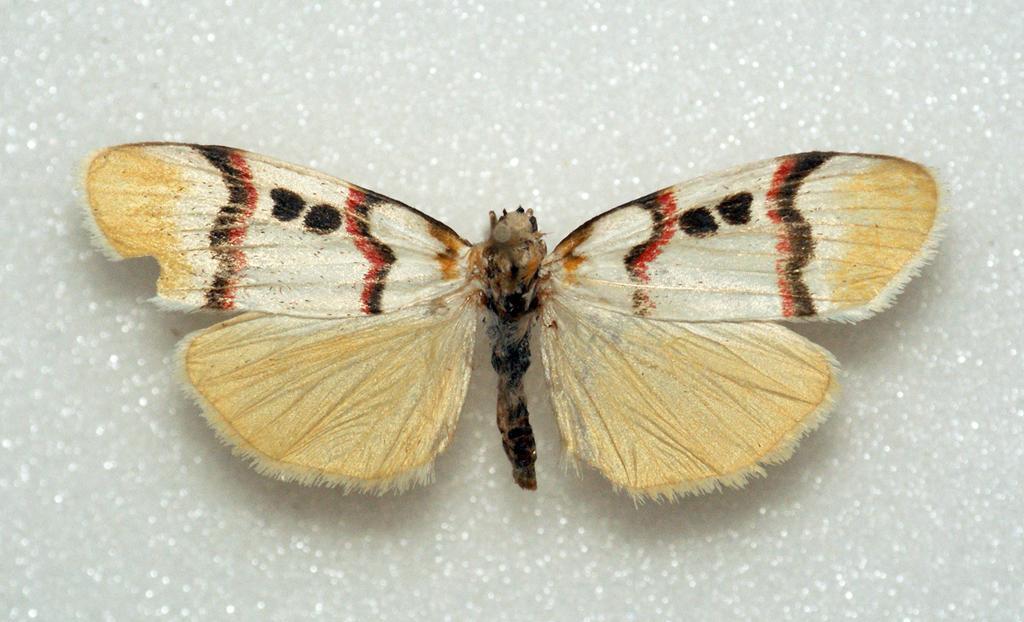Could you give a brief overview of what you see in this image? In this picture there is a butterfly. At the bottom it looks like a marble and the butterfly is in cream, red and in black color 